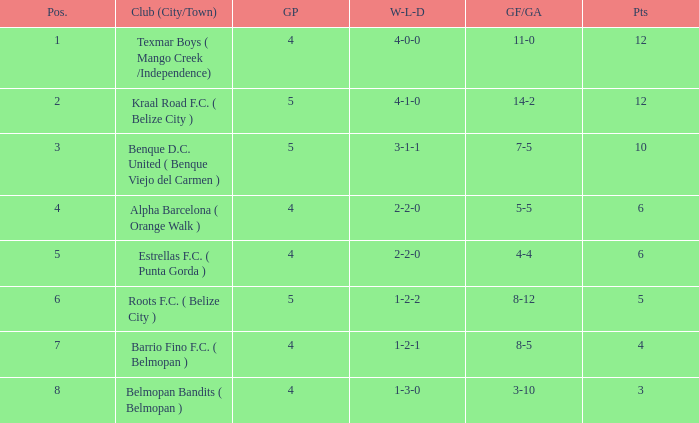What is the minimum games played with goals for/against being 7-5 5.0. 